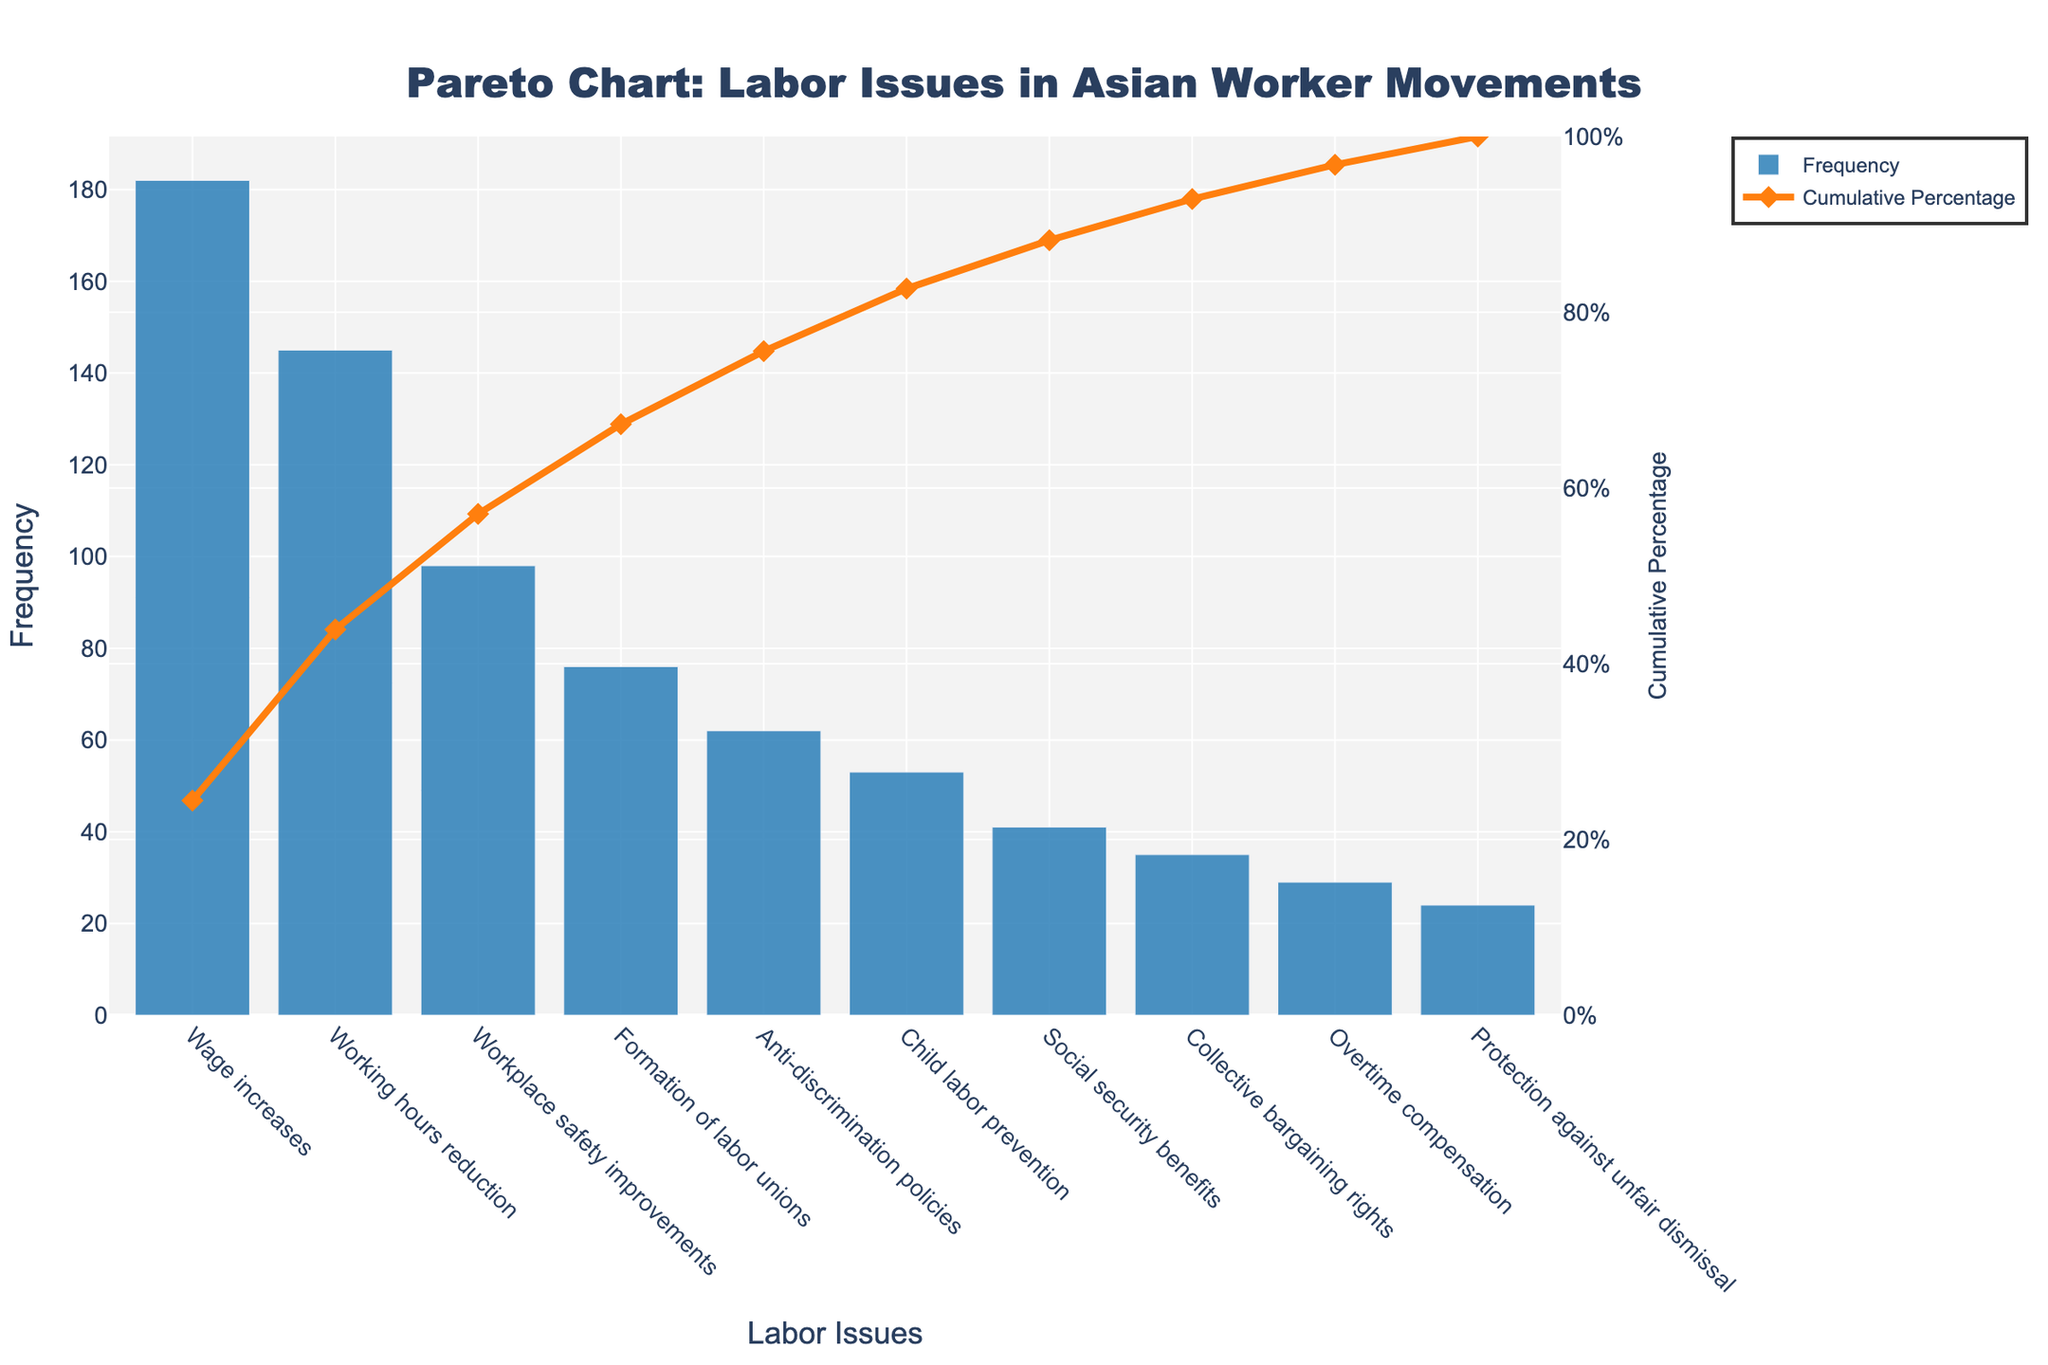Which labor issue has the highest frequency? The highest bar in the chart represents the most frequent labor issue, which is "Wage increases" with a frequency of 182.
Answer: Wage increases What is the cumulative percentage of the top two labor issues? The top two labor issues are "Wage increases" and "Working hours reduction." Their cumulative percentages are added as shown on the line plot: 42.98% (for Wage increases) + 33.30% (for Working hours reduction), summing up to 76.28%.
Answer: 76.28% Which labor issue's frequency reaches around the 80% cumulative percentage mark? By looking at the cumulative percentage line on the chart, the issue that approximately reaches the 80% mark is "Workplace safety improvements."
Answer: Workplace safety improvements How many labor issues have a frequency greater than 50? Count the bars that have a height (frequency) greater than 50. These issues are "Wage increases," "Working hours reduction," "Workplace safety improvements," "Formation of labor unions," and "Anti-discrimination policies," totaling 5 labor issues.
Answer: 5 What is the difference in frequency between "Formation of labor unions" and "Child labor prevention"? The frequency of "Formation of labor unions" is 76 and the frequency of "Child labor prevention" is 53. The difference is 76 - 53 = 23.
Answer: 23 Which labor issue is the least frequent and what is its frequency? The shortest bar in the chart represents the least frequent labor issue, which is "Protection against unfair dismissal" with a frequency of 24.
Answer: Protection against unfair dismissal, 24 What labor issues' cumulative percentages make up the top 50%? The issues contributing to the top 50% (first half of cumulative percentage) are found by looking at the cumulative percentage line until it crosses the 50% mark. These include "Wage increases" (42.98%) and part of "Working hours reduction" up to 50%.
Answer: Wage increases, part of Working hours reduction 